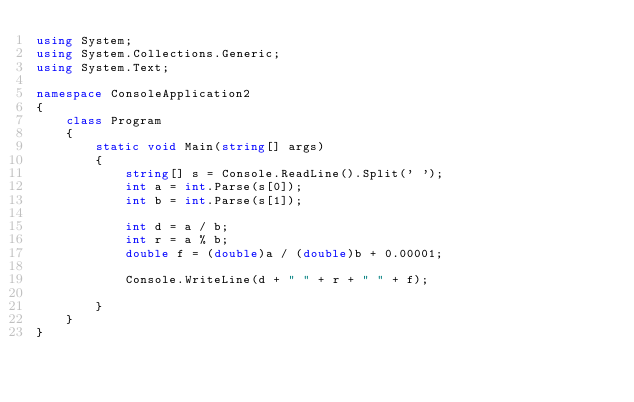<code> <loc_0><loc_0><loc_500><loc_500><_C#_>using System;
using System.Collections.Generic;
using System.Text;

namespace ConsoleApplication2
{
    class Program
    {
        static void Main(string[] args)
        {
            string[] s = Console.ReadLine().Split(' ');
            int a = int.Parse(s[0]);
            int b = int.Parse(s[1]);

            int d = a / b;
            int r = a % b;
            double f = (double)a / (double)b + 0.00001;

            Console.WriteLine(d + " " + r + " " + f);

        }
    }
}</code> 